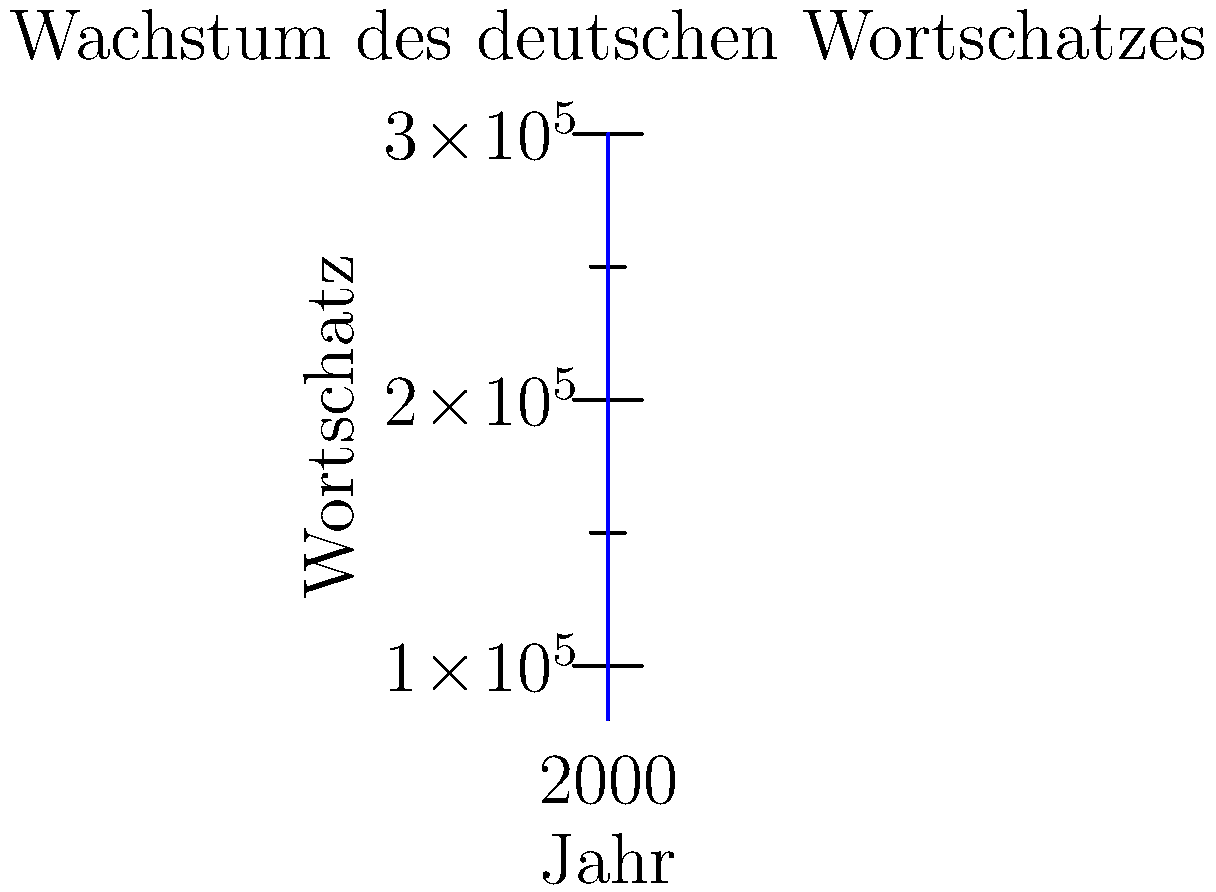Based on the line chart showing the growth of German vocabulary over time, what can you conclude about the rate of vocabulary growth between 1900 and 1950 compared to 1950 and 2000? To answer this question, we need to analyze the slope of the line between different time periods:

1. Calculate the slope between 1900 and 1950:
   $\text{Slope}_{1900-1950} = \frac{200000 - 150000}{1950 - 1900} = \frac{50000}{50} = 1000$ words per year

2. Calculate the slope between 1950 and 2000:
   $\text{Slope}_{1950-2000} = \frac{300000 - 200000}{2000 - 1950} = \frac{100000}{50} = 2000$ words per year

3. Compare the slopes:
   The slope from 1950 to 2000 (2000 words/year) is steeper than the slope from 1900 to 1950 (1000 words/year).

4. Interpret the results:
   A steeper slope indicates a faster rate of growth. Therefore, the rate of vocabulary growth was faster between 1950 and 2000 compared to 1900 and 1950.

This analysis aligns with the visual representation in the chart, where the line becomes steeper in the latter half of the 20th century.
Answer: The rate of vocabulary growth was faster between 1950 and 2000. 